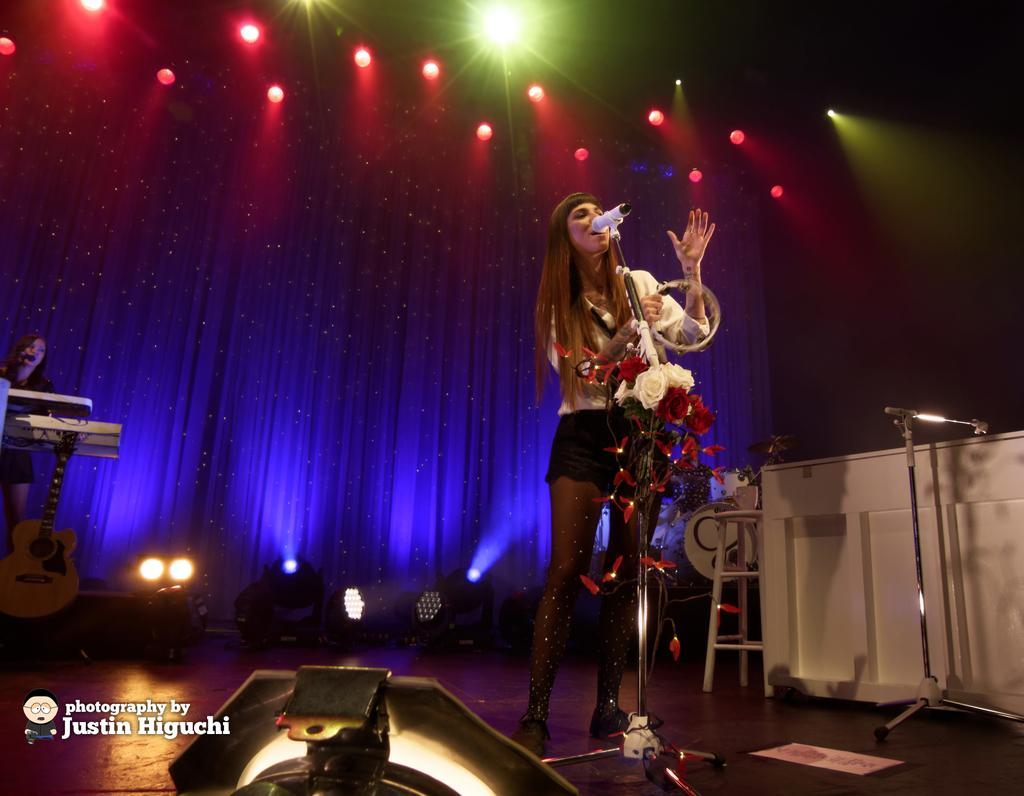Who is the main subject in the image? There is a woman in the image. What is the woman doing in the image? The woman is singing a song in the image. What tool is the woman using while singing? The woman is using a microphone in the image. What can be seen in the background of the image? There are lights visible in the image. What type of advice can be heard from the woman in the image? There is no indication in the image that the woman is giving advice; she is singing a song. 